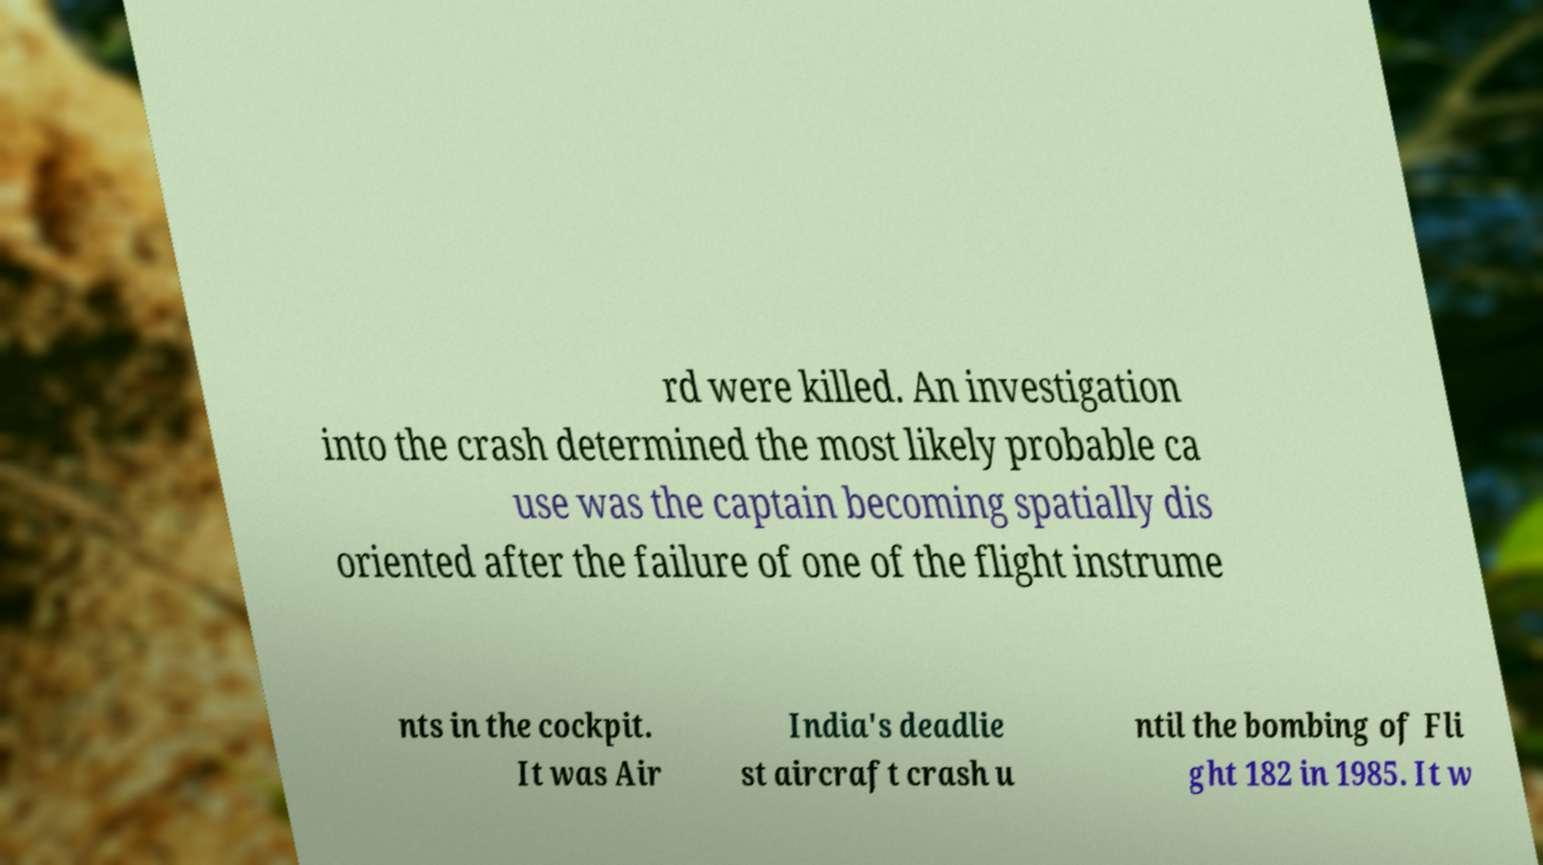Could you extract and type out the text from this image? rd were killed. An investigation into the crash determined the most likely probable ca use was the captain becoming spatially dis oriented after the failure of one of the flight instrume nts in the cockpit. It was Air India's deadlie st aircraft crash u ntil the bombing of Fli ght 182 in 1985. It w 